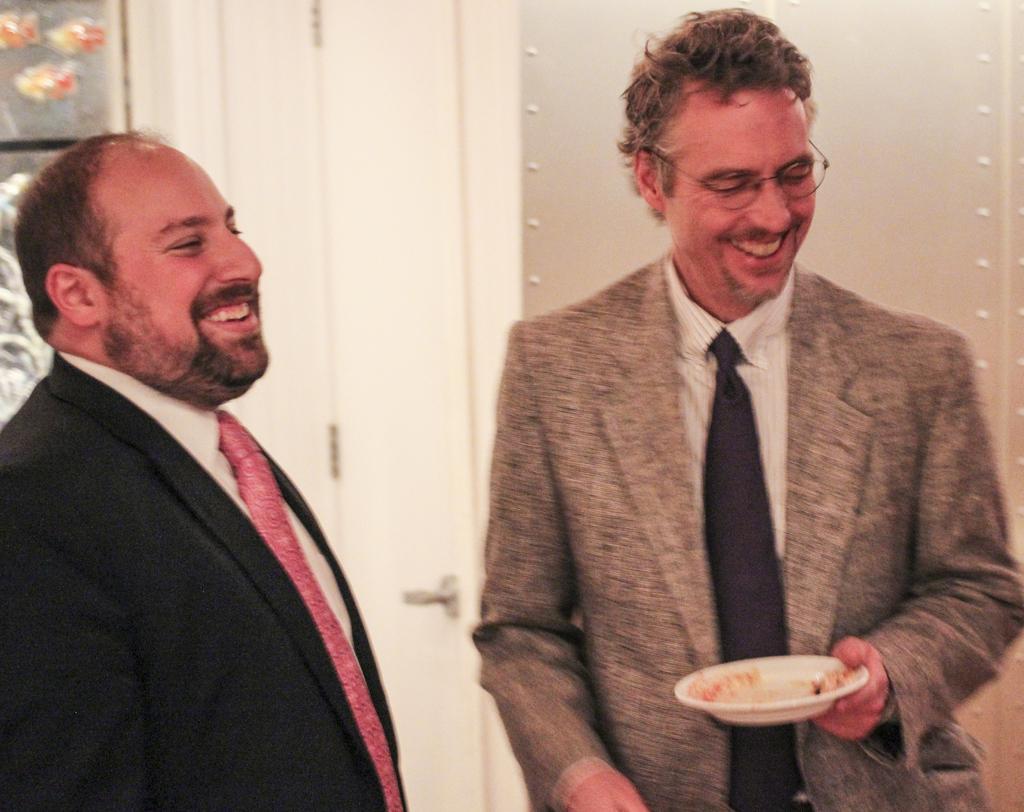Describe this image in one or two sentences. This picture seems to be clicked inside the room. On the right we can see a man wearing suit, smiling, holding a white color plate and standing. On the left we can see another man wearing black color suit, smiling and standing. In the background we can see the door, wall and some other objects. 